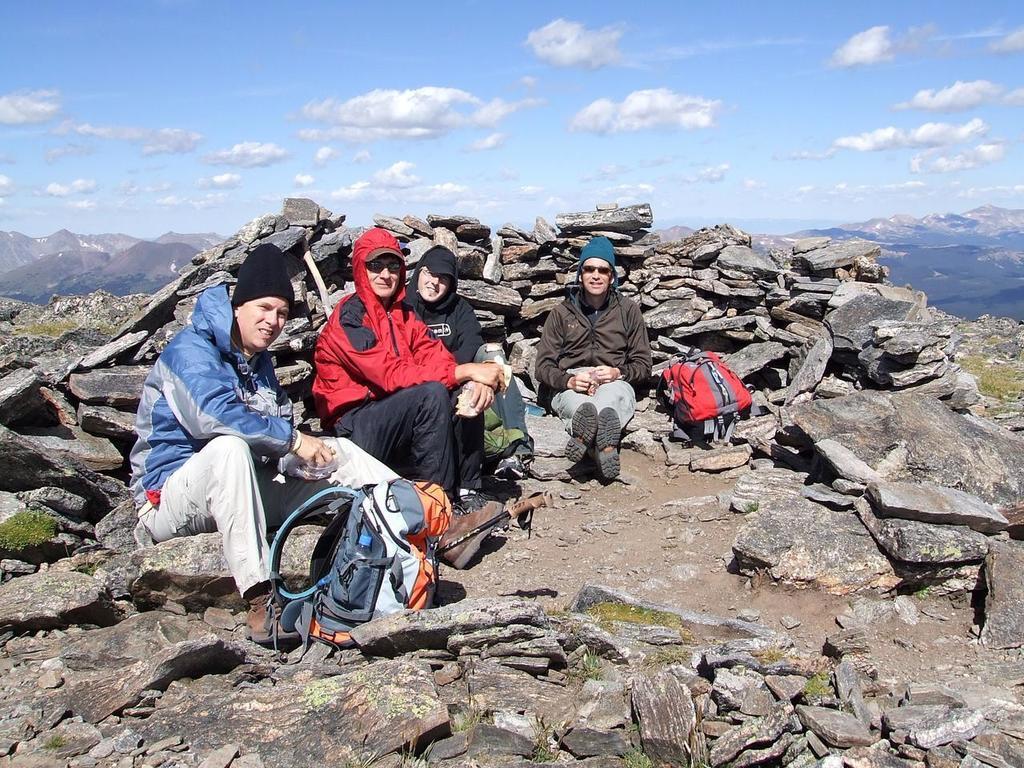How would you summarize this image in a sentence or two? As we can see in the image there are rocks, few people sitting in the front, bags, bottle, sky and clouds. 